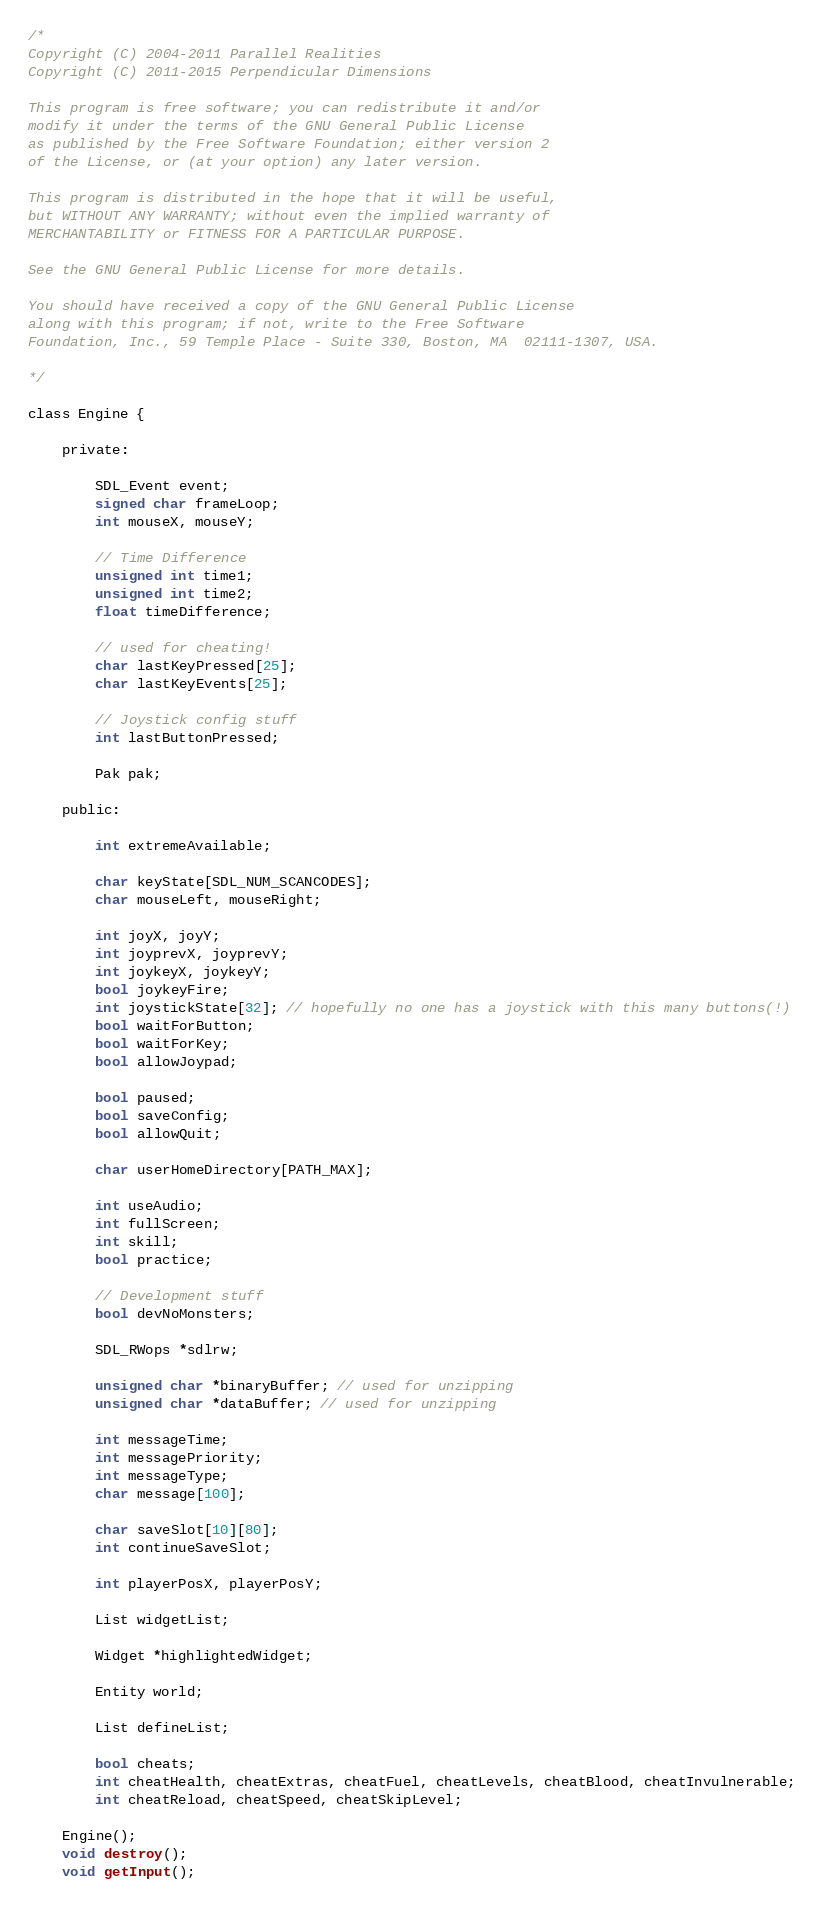<code> <loc_0><loc_0><loc_500><loc_500><_C_>/*
Copyright (C) 2004-2011 Parallel Realities
Copyright (C) 2011-2015 Perpendicular Dimensions

This program is free software; you can redistribute it and/or
modify it under the terms of the GNU General Public License
as published by the Free Software Foundation; either version 2
of the License, or (at your option) any later version.

This program is distributed in the hope that it will be useful,
but WITHOUT ANY WARRANTY; without even the implied warranty of
MERCHANTABILITY or FITNESS FOR A PARTICULAR PURPOSE.

See the GNU General Public License for more details.

You should have received a copy of the GNU General Public License
along with this program; if not, write to the Free Software
Foundation, Inc., 59 Temple Place - Suite 330, Boston, MA  02111-1307, USA.

*/

class Engine {

	private:

		SDL_Event event;
		signed char frameLoop;
		int mouseX, mouseY;

		// Time Difference
		unsigned int time1;
		unsigned int time2;
		float timeDifference;
		
		// used for cheating!
		char lastKeyPressed[25];
		char lastKeyEvents[25];
		
		// Joystick config stuff
		int lastButtonPressed;
		
		Pak pak;

	public:
		
		int extremeAvailable;

		char keyState[SDL_NUM_SCANCODES];
		char mouseLeft, mouseRight;
		
		int joyX, joyY;
		int joyprevX, joyprevY;
		int joykeyX, joykeyY;
		bool joykeyFire;
		int joystickState[32]; // hopefully no one has a joystick with this many buttons(!)
		bool waitForButton;
		bool waitForKey;
		bool allowJoypad;

		bool paused;
		bool saveConfig;
		bool allowQuit;

		char userHomeDirectory[PATH_MAX];

		int useAudio;
		int fullScreen;
		int skill;
		bool practice;

		// Development stuff
		bool devNoMonsters;

		SDL_RWops *sdlrw;

		unsigned char *binaryBuffer; // used for unzipping
		unsigned char *dataBuffer; // used for unzipping

		int messageTime;
		int messagePriority;
		int messageType;
		char message[100];

		char saveSlot[10][80];
		int continueSaveSlot;

		int playerPosX, playerPosY;

		List widgetList;

		Widget *highlightedWidget;

		Entity world;

		List defineList;

		bool cheats;
		int cheatHealth, cheatExtras, cheatFuel, cheatLevels, cheatBlood, cheatInvulnerable;
		int cheatReload, cheatSpeed, cheatSkipLevel;

	Engine();
	void destroy();
	void getInput();</code> 